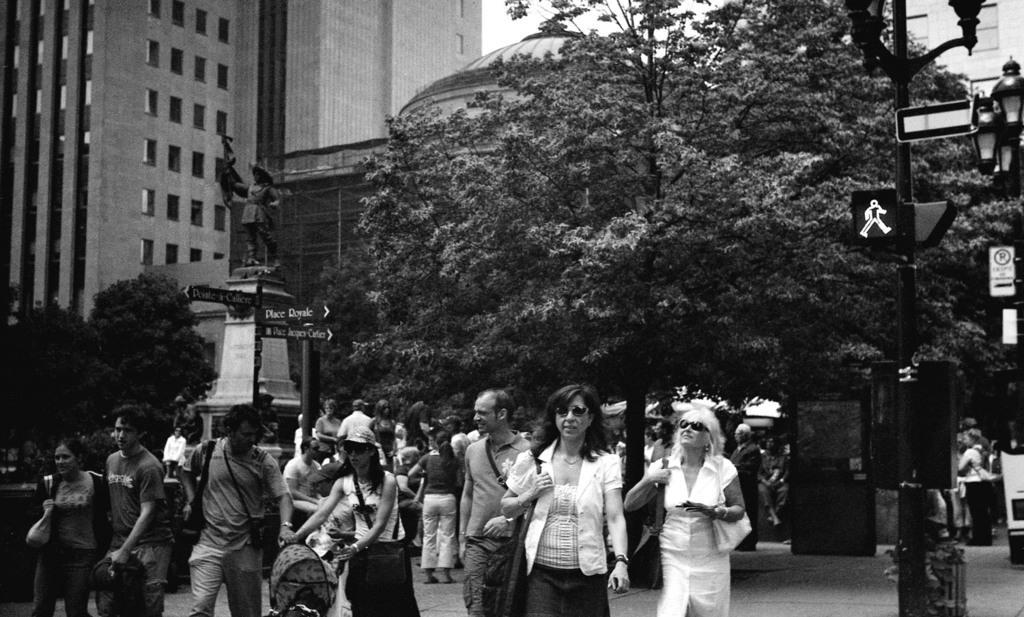Please provide a concise description of this image. This is a black and white image, where we can see a group of people walking and a few of them are carrying bags and other objects, behind them there are trees, on the left side of the image there is a statue and a directional board, behind it there are trees and buildings, on the right side of the image there are traffic lights, street lights and a few other objects. 